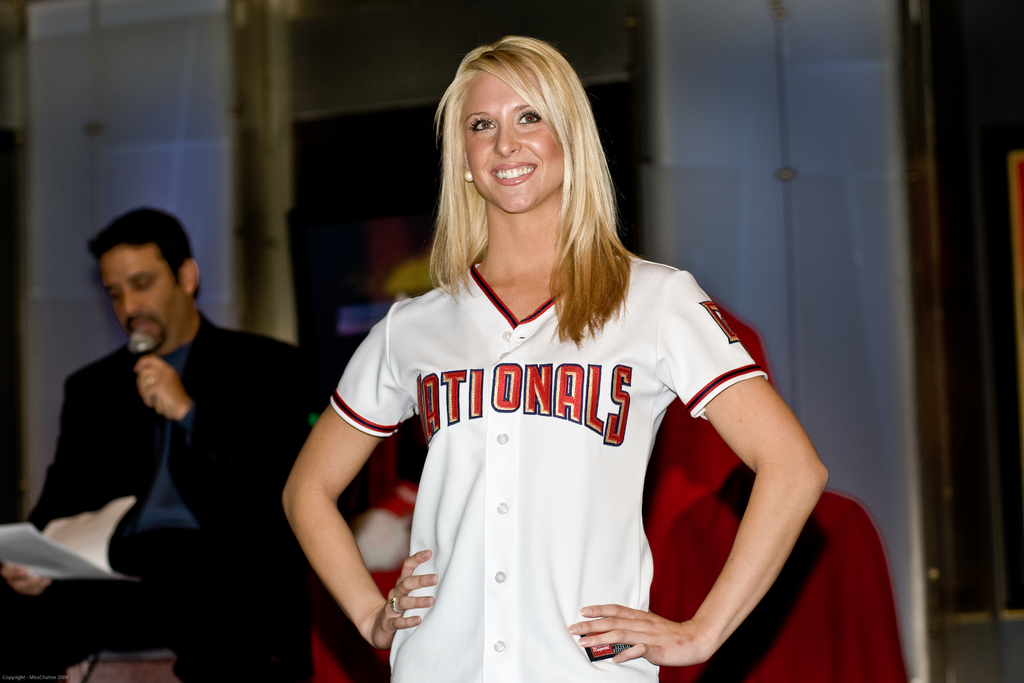Provide a one-sentence caption for the provided image.
Reference OCR token: IT, ONALS A blonde woman wears a jersey bearing the name Nationals. 